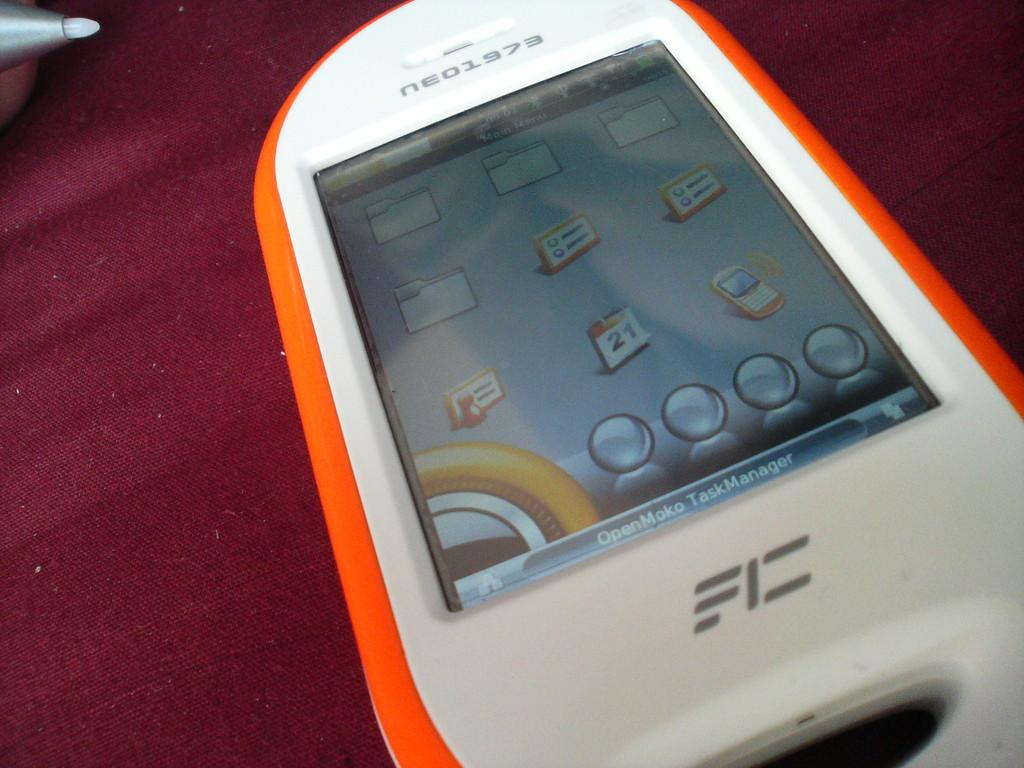<image>
Share a concise interpretation of the image provided. A orange and white smart phone that says neo1973 on it. 